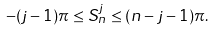<formula> <loc_0><loc_0><loc_500><loc_500>- ( j - 1 ) \pi \leq S _ { n } ^ { j } \leq ( n - j - 1 ) \pi .</formula> 